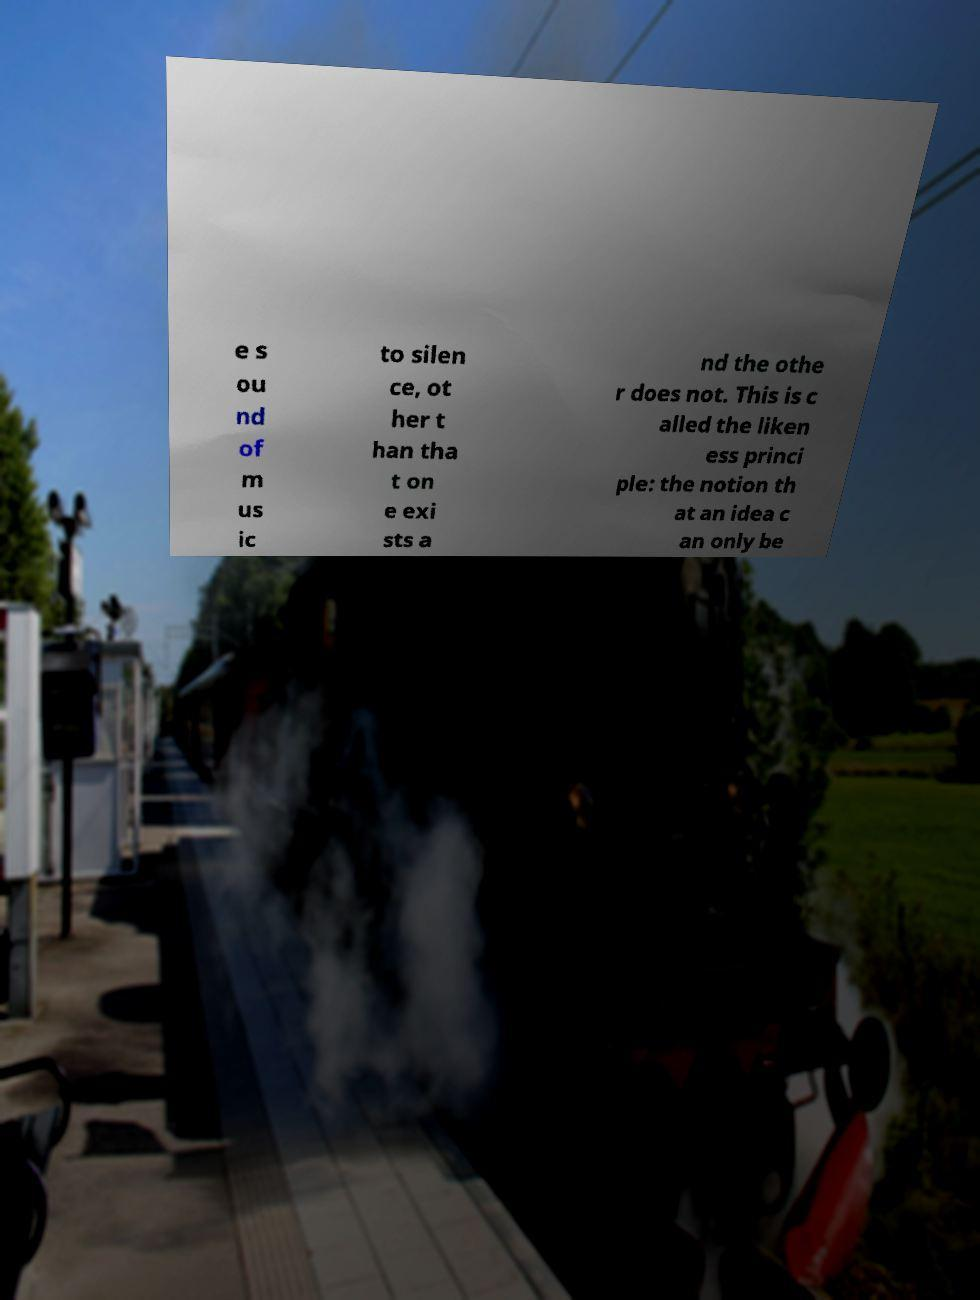Please read and relay the text visible in this image. What does it say? e s ou nd of m us ic to silen ce, ot her t han tha t on e exi sts a nd the othe r does not. This is c alled the liken ess princi ple: the notion th at an idea c an only be 